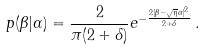Convert formula to latex. <formula><loc_0><loc_0><loc_500><loc_500>p ( \beta | \alpha ) = \frac { 2 } { \pi ( 2 + \delta ) } e ^ { - \frac { 2 | \beta - \sqrt { \eta } \alpha | ^ { 2 } } { 2 + \delta } } \, .</formula> 